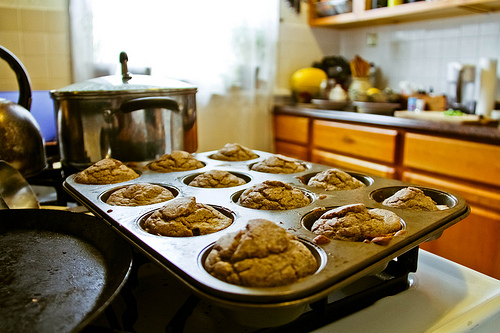<image>
Is the muffin in the bake pan? Yes. The muffin is contained within or inside the bake pan, showing a containment relationship. 